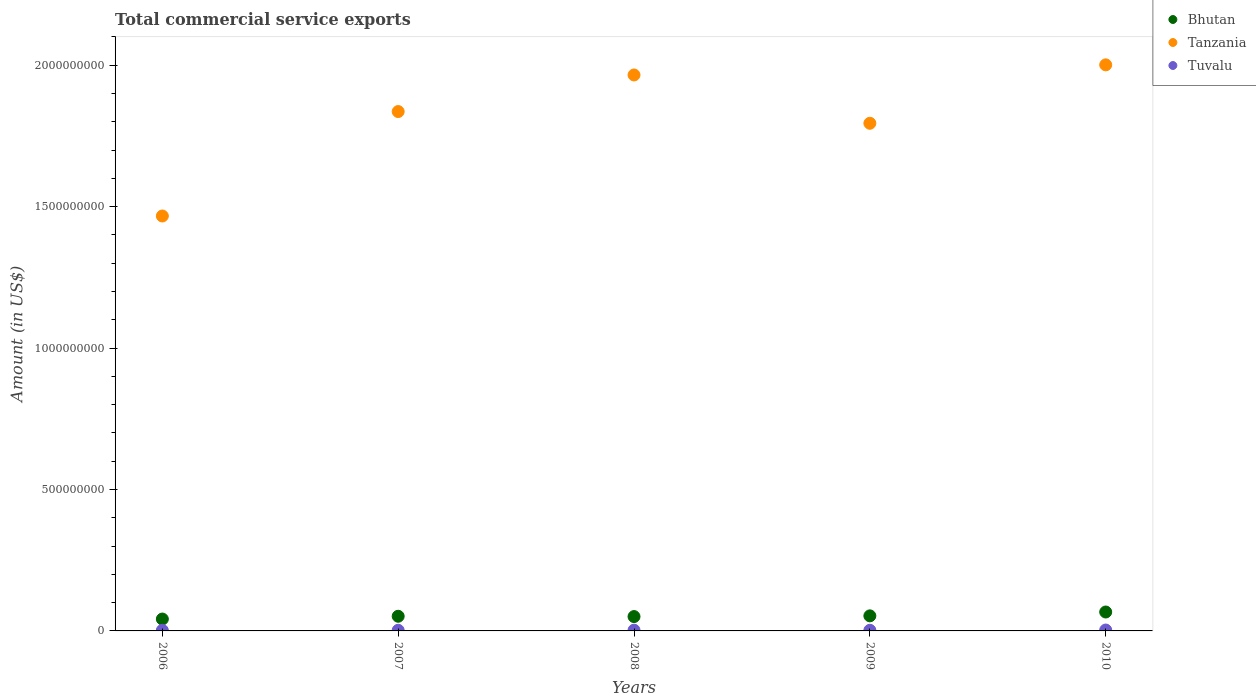How many different coloured dotlines are there?
Your answer should be compact. 3. What is the total commercial service exports in Bhutan in 2007?
Provide a succinct answer. 5.18e+07. Across all years, what is the maximum total commercial service exports in Tuvalu?
Keep it short and to the point. 3.19e+06. Across all years, what is the minimum total commercial service exports in Tanzania?
Provide a short and direct response. 1.47e+09. In which year was the total commercial service exports in Tanzania maximum?
Your response must be concise. 2010. What is the total total commercial service exports in Tanzania in the graph?
Provide a succinct answer. 9.07e+09. What is the difference between the total commercial service exports in Tanzania in 2007 and that in 2010?
Offer a very short reply. -1.65e+08. What is the difference between the total commercial service exports in Bhutan in 2006 and the total commercial service exports in Tuvalu in 2010?
Keep it short and to the point. 3.88e+07. What is the average total commercial service exports in Tuvalu per year?
Your answer should be very brief. 2.50e+06. In the year 2007, what is the difference between the total commercial service exports in Tuvalu and total commercial service exports in Tanzania?
Provide a succinct answer. -1.83e+09. What is the ratio of the total commercial service exports in Tuvalu in 2008 to that in 2010?
Provide a succinct answer. 0.85. Is the difference between the total commercial service exports in Tuvalu in 2006 and 2010 greater than the difference between the total commercial service exports in Tanzania in 2006 and 2010?
Give a very brief answer. Yes. What is the difference between the highest and the second highest total commercial service exports in Tuvalu?
Ensure brevity in your answer.  4.86e+05. What is the difference between the highest and the lowest total commercial service exports in Tuvalu?
Give a very brief answer. 1.12e+06. Is it the case that in every year, the sum of the total commercial service exports in Tuvalu and total commercial service exports in Bhutan  is greater than the total commercial service exports in Tanzania?
Keep it short and to the point. No. How many years are there in the graph?
Ensure brevity in your answer.  5. What is the difference between two consecutive major ticks on the Y-axis?
Make the answer very short. 5.00e+08. Are the values on the major ticks of Y-axis written in scientific E-notation?
Your response must be concise. No. Does the graph contain any zero values?
Ensure brevity in your answer.  No. Where does the legend appear in the graph?
Ensure brevity in your answer.  Top right. How many legend labels are there?
Your answer should be compact. 3. What is the title of the graph?
Your answer should be compact. Total commercial service exports. What is the label or title of the Y-axis?
Your answer should be compact. Amount (in US$). What is the Amount (in US$) in Bhutan in 2006?
Your answer should be very brief. 4.20e+07. What is the Amount (in US$) of Tanzania in 2006?
Offer a terse response. 1.47e+09. What is the Amount (in US$) in Tuvalu in 2006?
Offer a very short reply. 2.06e+06. What is the Amount (in US$) in Bhutan in 2007?
Your answer should be compact. 5.18e+07. What is the Amount (in US$) in Tanzania in 2007?
Your response must be concise. 1.84e+09. What is the Amount (in US$) in Tuvalu in 2007?
Offer a terse response. 2.27e+06. What is the Amount (in US$) of Bhutan in 2008?
Provide a short and direct response. 5.07e+07. What is the Amount (in US$) of Tanzania in 2008?
Keep it short and to the point. 1.97e+09. What is the Amount (in US$) of Tuvalu in 2008?
Offer a very short reply. 2.70e+06. What is the Amount (in US$) of Bhutan in 2009?
Your answer should be compact. 5.33e+07. What is the Amount (in US$) of Tanzania in 2009?
Keep it short and to the point. 1.79e+09. What is the Amount (in US$) of Tuvalu in 2009?
Offer a terse response. 2.27e+06. What is the Amount (in US$) in Bhutan in 2010?
Your response must be concise. 6.69e+07. What is the Amount (in US$) of Tanzania in 2010?
Make the answer very short. 2.00e+09. What is the Amount (in US$) of Tuvalu in 2010?
Make the answer very short. 3.19e+06. Across all years, what is the maximum Amount (in US$) in Bhutan?
Give a very brief answer. 6.69e+07. Across all years, what is the maximum Amount (in US$) in Tanzania?
Make the answer very short. 2.00e+09. Across all years, what is the maximum Amount (in US$) in Tuvalu?
Your response must be concise. 3.19e+06. Across all years, what is the minimum Amount (in US$) of Bhutan?
Ensure brevity in your answer.  4.20e+07. Across all years, what is the minimum Amount (in US$) of Tanzania?
Make the answer very short. 1.47e+09. Across all years, what is the minimum Amount (in US$) of Tuvalu?
Your response must be concise. 2.06e+06. What is the total Amount (in US$) in Bhutan in the graph?
Make the answer very short. 2.65e+08. What is the total Amount (in US$) in Tanzania in the graph?
Your answer should be very brief. 9.07e+09. What is the total Amount (in US$) of Tuvalu in the graph?
Make the answer very short. 1.25e+07. What is the difference between the Amount (in US$) of Bhutan in 2006 and that in 2007?
Make the answer very short. -9.80e+06. What is the difference between the Amount (in US$) in Tanzania in 2006 and that in 2007?
Provide a succinct answer. -3.69e+08. What is the difference between the Amount (in US$) of Tuvalu in 2006 and that in 2007?
Your answer should be very brief. -2.13e+05. What is the difference between the Amount (in US$) of Bhutan in 2006 and that in 2008?
Your answer should be compact. -8.72e+06. What is the difference between the Amount (in US$) of Tanzania in 2006 and that in 2008?
Offer a very short reply. -4.99e+08. What is the difference between the Amount (in US$) in Tuvalu in 2006 and that in 2008?
Your answer should be compact. -6.38e+05. What is the difference between the Amount (in US$) of Bhutan in 2006 and that in 2009?
Provide a succinct answer. -1.13e+07. What is the difference between the Amount (in US$) in Tanzania in 2006 and that in 2009?
Your answer should be compact. -3.28e+08. What is the difference between the Amount (in US$) in Tuvalu in 2006 and that in 2009?
Offer a terse response. -2.10e+05. What is the difference between the Amount (in US$) of Bhutan in 2006 and that in 2010?
Keep it short and to the point. -2.49e+07. What is the difference between the Amount (in US$) in Tanzania in 2006 and that in 2010?
Your answer should be very brief. -5.34e+08. What is the difference between the Amount (in US$) in Tuvalu in 2006 and that in 2010?
Make the answer very short. -1.12e+06. What is the difference between the Amount (in US$) of Bhutan in 2007 and that in 2008?
Ensure brevity in your answer.  1.08e+06. What is the difference between the Amount (in US$) of Tanzania in 2007 and that in 2008?
Provide a short and direct response. -1.29e+08. What is the difference between the Amount (in US$) in Tuvalu in 2007 and that in 2008?
Your answer should be compact. -4.25e+05. What is the difference between the Amount (in US$) of Bhutan in 2007 and that in 2009?
Provide a succinct answer. -1.45e+06. What is the difference between the Amount (in US$) in Tanzania in 2007 and that in 2009?
Provide a succinct answer. 4.15e+07. What is the difference between the Amount (in US$) of Tuvalu in 2007 and that in 2009?
Your answer should be very brief. 2832.59. What is the difference between the Amount (in US$) of Bhutan in 2007 and that in 2010?
Provide a short and direct response. -1.51e+07. What is the difference between the Amount (in US$) in Tanzania in 2007 and that in 2010?
Make the answer very short. -1.65e+08. What is the difference between the Amount (in US$) in Tuvalu in 2007 and that in 2010?
Your answer should be very brief. -9.11e+05. What is the difference between the Amount (in US$) of Bhutan in 2008 and that in 2009?
Your answer should be very brief. -2.53e+06. What is the difference between the Amount (in US$) of Tanzania in 2008 and that in 2009?
Ensure brevity in your answer.  1.71e+08. What is the difference between the Amount (in US$) of Tuvalu in 2008 and that in 2009?
Give a very brief answer. 4.28e+05. What is the difference between the Amount (in US$) in Bhutan in 2008 and that in 2010?
Provide a succinct answer. -1.62e+07. What is the difference between the Amount (in US$) of Tanzania in 2008 and that in 2010?
Keep it short and to the point. -3.58e+07. What is the difference between the Amount (in US$) of Tuvalu in 2008 and that in 2010?
Keep it short and to the point. -4.86e+05. What is the difference between the Amount (in US$) of Bhutan in 2009 and that in 2010?
Your response must be concise. -1.36e+07. What is the difference between the Amount (in US$) of Tanzania in 2009 and that in 2010?
Your response must be concise. -2.07e+08. What is the difference between the Amount (in US$) in Tuvalu in 2009 and that in 2010?
Your response must be concise. -9.14e+05. What is the difference between the Amount (in US$) of Bhutan in 2006 and the Amount (in US$) of Tanzania in 2007?
Offer a very short reply. -1.79e+09. What is the difference between the Amount (in US$) of Bhutan in 2006 and the Amount (in US$) of Tuvalu in 2007?
Your response must be concise. 3.97e+07. What is the difference between the Amount (in US$) of Tanzania in 2006 and the Amount (in US$) of Tuvalu in 2007?
Provide a succinct answer. 1.46e+09. What is the difference between the Amount (in US$) in Bhutan in 2006 and the Amount (in US$) in Tanzania in 2008?
Keep it short and to the point. -1.92e+09. What is the difference between the Amount (in US$) of Bhutan in 2006 and the Amount (in US$) of Tuvalu in 2008?
Provide a succinct answer. 3.93e+07. What is the difference between the Amount (in US$) in Tanzania in 2006 and the Amount (in US$) in Tuvalu in 2008?
Offer a terse response. 1.46e+09. What is the difference between the Amount (in US$) of Bhutan in 2006 and the Amount (in US$) of Tanzania in 2009?
Your response must be concise. -1.75e+09. What is the difference between the Amount (in US$) of Bhutan in 2006 and the Amount (in US$) of Tuvalu in 2009?
Offer a terse response. 3.97e+07. What is the difference between the Amount (in US$) of Tanzania in 2006 and the Amount (in US$) of Tuvalu in 2009?
Offer a terse response. 1.46e+09. What is the difference between the Amount (in US$) in Bhutan in 2006 and the Amount (in US$) in Tanzania in 2010?
Provide a succinct answer. -1.96e+09. What is the difference between the Amount (in US$) in Bhutan in 2006 and the Amount (in US$) in Tuvalu in 2010?
Provide a succinct answer. 3.88e+07. What is the difference between the Amount (in US$) in Tanzania in 2006 and the Amount (in US$) in Tuvalu in 2010?
Offer a terse response. 1.46e+09. What is the difference between the Amount (in US$) in Bhutan in 2007 and the Amount (in US$) in Tanzania in 2008?
Provide a succinct answer. -1.91e+09. What is the difference between the Amount (in US$) in Bhutan in 2007 and the Amount (in US$) in Tuvalu in 2008?
Your answer should be very brief. 4.91e+07. What is the difference between the Amount (in US$) of Tanzania in 2007 and the Amount (in US$) of Tuvalu in 2008?
Your answer should be very brief. 1.83e+09. What is the difference between the Amount (in US$) in Bhutan in 2007 and the Amount (in US$) in Tanzania in 2009?
Make the answer very short. -1.74e+09. What is the difference between the Amount (in US$) in Bhutan in 2007 and the Amount (in US$) in Tuvalu in 2009?
Make the answer very short. 4.95e+07. What is the difference between the Amount (in US$) in Tanzania in 2007 and the Amount (in US$) in Tuvalu in 2009?
Offer a very short reply. 1.83e+09. What is the difference between the Amount (in US$) of Bhutan in 2007 and the Amount (in US$) of Tanzania in 2010?
Offer a terse response. -1.95e+09. What is the difference between the Amount (in US$) of Bhutan in 2007 and the Amount (in US$) of Tuvalu in 2010?
Your response must be concise. 4.86e+07. What is the difference between the Amount (in US$) in Tanzania in 2007 and the Amount (in US$) in Tuvalu in 2010?
Your answer should be compact. 1.83e+09. What is the difference between the Amount (in US$) in Bhutan in 2008 and the Amount (in US$) in Tanzania in 2009?
Offer a terse response. -1.74e+09. What is the difference between the Amount (in US$) in Bhutan in 2008 and the Amount (in US$) in Tuvalu in 2009?
Keep it short and to the point. 4.85e+07. What is the difference between the Amount (in US$) in Tanzania in 2008 and the Amount (in US$) in Tuvalu in 2009?
Offer a terse response. 1.96e+09. What is the difference between the Amount (in US$) of Bhutan in 2008 and the Amount (in US$) of Tanzania in 2010?
Give a very brief answer. -1.95e+09. What is the difference between the Amount (in US$) in Bhutan in 2008 and the Amount (in US$) in Tuvalu in 2010?
Your response must be concise. 4.75e+07. What is the difference between the Amount (in US$) in Tanzania in 2008 and the Amount (in US$) in Tuvalu in 2010?
Your answer should be compact. 1.96e+09. What is the difference between the Amount (in US$) of Bhutan in 2009 and the Amount (in US$) of Tanzania in 2010?
Ensure brevity in your answer.  -1.95e+09. What is the difference between the Amount (in US$) of Bhutan in 2009 and the Amount (in US$) of Tuvalu in 2010?
Your answer should be very brief. 5.01e+07. What is the difference between the Amount (in US$) of Tanzania in 2009 and the Amount (in US$) of Tuvalu in 2010?
Ensure brevity in your answer.  1.79e+09. What is the average Amount (in US$) of Bhutan per year?
Offer a very short reply. 5.29e+07. What is the average Amount (in US$) of Tanzania per year?
Your answer should be very brief. 1.81e+09. What is the average Amount (in US$) of Tuvalu per year?
Ensure brevity in your answer.  2.50e+06. In the year 2006, what is the difference between the Amount (in US$) of Bhutan and Amount (in US$) of Tanzania?
Keep it short and to the point. -1.43e+09. In the year 2006, what is the difference between the Amount (in US$) of Bhutan and Amount (in US$) of Tuvalu?
Provide a short and direct response. 3.99e+07. In the year 2006, what is the difference between the Amount (in US$) of Tanzania and Amount (in US$) of Tuvalu?
Your answer should be very brief. 1.46e+09. In the year 2007, what is the difference between the Amount (in US$) of Bhutan and Amount (in US$) of Tanzania?
Your answer should be compact. -1.78e+09. In the year 2007, what is the difference between the Amount (in US$) of Bhutan and Amount (in US$) of Tuvalu?
Provide a succinct answer. 4.95e+07. In the year 2007, what is the difference between the Amount (in US$) in Tanzania and Amount (in US$) in Tuvalu?
Ensure brevity in your answer.  1.83e+09. In the year 2008, what is the difference between the Amount (in US$) in Bhutan and Amount (in US$) in Tanzania?
Your answer should be compact. -1.91e+09. In the year 2008, what is the difference between the Amount (in US$) of Bhutan and Amount (in US$) of Tuvalu?
Your answer should be very brief. 4.80e+07. In the year 2008, what is the difference between the Amount (in US$) in Tanzania and Amount (in US$) in Tuvalu?
Offer a very short reply. 1.96e+09. In the year 2009, what is the difference between the Amount (in US$) in Bhutan and Amount (in US$) in Tanzania?
Provide a short and direct response. -1.74e+09. In the year 2009, what is the difference between the Amount (in US$) in Bhutan and Amount (in US$) in Tuvalu?
Your answer should be very brief. 5.10e+07. In the year 2009, what is the difference between the Amount (in US$) of Tanzania and Amount (in US$) of Tuvalu?
Provide a short and direct response. 1.79e+09. In the year 2010, what is the difference between the Amount (in US$) of Bhutan and Amount (in US$) of Tanzania?
Offer a very short reply. -1.93e+09. In the year 2010, what is the difference between the Amount (in US$) of Bhutan and Amount (in US$) of Tuvalu?
Your response must be concise. 6.37e+07. In the year 2010, what is the difference between the Amount (in US$) in Tanzania and Amount (in US$) in Tuvalu?
Your answer should be very brief. 2.00e+09. What is the ratio of the Amount (in US$) of Bhutan in 2006 to that in 2007?
Make the answer very short. 0.81. What is the ratio of the Amount (in US$) of Tanzania in 2006 to that in 2007?
Provide a short and direct response. 0.8. What is the ratio of the Amount (in US$) in Tuvalu in 2006 to that in 2007?
Offer a terse response. 0.91. What is the ratio of the Amount (in US$) of Bhutan in 2006 to that in 2008?
Keep it short and to the point. 0.83. What is the ratio of the Amount (in US$) of Tanzania in 2006 to that in 2008?
Provide a short and direct response. 0.75. What is the ratio of the Amount (in US$) in Tuvalu in 2006 to that in 2008?
Keep it short and to the point. 0.76. What is the ratio of the Amount (in US$) in Bhutan in 2006 to that in 2009?
Offer a terse response. 0.79. What is the ratio of the Amount (in US$) of Tanzania in 2006 to that in 2009?
Your answer should be compact. 0.82. What is the ratio of the Amount (in US$) of Tuvalu in 2006 to that in 2009?
Offer a very short reply. 0.91. What is the ratio of the Amount (in US$) of Bhutan in 2006 to that in 2010?
Give a very brief answer. 0.63. What is the ratio of the Amount (in US$) of Tanzania in 2006 to that in 2010?
Your response must be concise. 0.73. What is the ratio of the Amount (in US$) in Tuvalu in 2006 to that in 2010?
Offer a terse response. 0.65. What is the ratio of the Amount (in US$) in Bhutan in 2007 to that in 2008?
Provide a short and direct response. 1.02. What is the ratio of the Amount (in US$) in Tanzania in 2007 to that in 2008?
Ensure brevity in your answer.  0.93. What is the ratio of the Amount (in US$) in Tuvalu in 2007 to that in 2008?
Keep it short and to the point. 0.84. What is the ratio of the Amount (in US$) of Bhutan in 2007 to that in 2009?
Offer a very short reply. 0.97. What is the ratio of the Amount (in US$) in Tanzania in 2007 to that in 2009?
Keep it short and to the point. 1.02. What is the ratio of the Amount (in US$) of Tuvalu in 2007 to that in 2009?
Give a very brief answer. 1. What is the ratio of the Amount (in US$) in Bhutan in 2007 to that in 2010?
Keep it short and to the point. 0.77. What is the ratio of the Amount (in US$) in Tanzania in 2007 to that in 2010?
Keep it short and to the point. 0.92. What is the ratio of the Amount (in US$) in Tuvalu in 2007 to that in 2010?
Your answer should be very brief. 0.71. What is the ratio of the Amount (in US$) of Tanzania in 2008 to that in 2009?
Your answer should be compact. 1.1. What is the ratio of the Amount (in US$) in Tuvalu in 2008 to that in 2009?
Your answer should be very brief. 1.19. What is the ratio of the Amount (in US$) in Bhutan in 2008 to that in 2010?
Your answer should be very brief. 0.76. What is the ratio of the Amount (in US$) of Tanzania in 2008 to that in 2010?
Give a very brief answer. 0.98. What is the ratio of the Amount (in US$) of Tuvalu in 2008 to that in 2010?
Make the answer very short. 0.85. What is the ratio of the Amount (in US$) in Bhutan in 2009 to that in 2010?
Offer a terse response. 0.8. What is the ratio of the Amount (in US$) of Tanzania in 2009 to that in 2010?
Make the answer very short. 0.9. What is the ratio of the Amount (in US$) of Tuvalu in 2009 to that in 2010?
Offer a terse response. 0.71. What is the difference between the highest and the second highest Amount (in US$) of Bhutan?
Offer a terse response. 1.36e+07. What is the difference between the highest and the second highest Amount (in US$) in Tanzania?
Offer a terse response. 3.58e+07. What is the difference between the highest and the second highest Amount (in US$) in Tuvalu?
Your answer should be compact. 4.86e+05. What is the difference between the highest and the lowest Amount (in US$) in Bhutan?
Your answer should be compact. 2.49e+07. What is the difference between the highest and the lowest Amount (in US$) in Tanzania?
Provide a succinct answer. 5.34e+08. What is the difference between the highest and the lowest Amount (in US$) in Tuvalu?
Offer a terse response. 1.12e+06. 